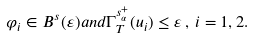Convert formula to latex. <formula><loc_0><loc_0><loc_500><loc_500>\varphi _ { i } \in B ^ { s } ( \varepsilon ) a n d \Gamma _ { T } ^ { s _ { \alpha } ^ { + } } ( u _ { i } ) \leq \varepsilon \, , \, i = 1 , 2 .</formula> 